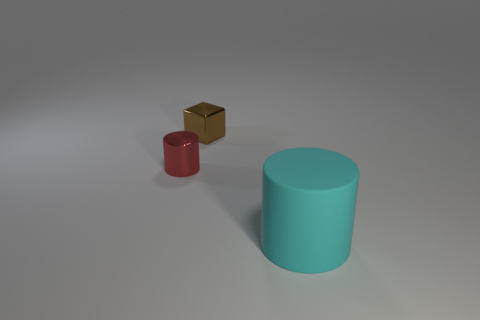Is there any other thing that has the same material as the cyan object?
Keep it short and to the point. No. There is a object that is behind the cylinder to the left of the big cyan object; what is its shape?
Provide a succinct answer. Cube. Are there an equal number of small brown metallic blocks in front of the small red cylinder and gray shiny cubes?
Provide a short and direct response. Yes. What is the material of the cylinder on the right side of the cylinder to the left of the tiny metallic object behind the tiny red metal thing?
Provide a short and direct response. Rubber. Is there a red object of the same size as the brown shiny object?
Your response must be concise. Yes. What shape is the tiny red thing?
Keep it short and to the point. Cylinder. How many cubes are either tiny brown rubber objects or small red objects?
Offer a terse response. 0. Are there the same number of cylinders behind the brown block and rubber cylinders right of the large cyan cylinder?
Your answer should be very brief. Yes. There is a cylinder that is left of the cylinder that is on the right side of the brown cube; what number of objects are behind it?
Give a very brief answer. 1. Is the number of large matte cylinders in front of the red thing greater than the number of big shiny objects?
Your response must be concise. Yes. 